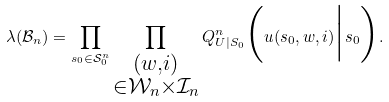Convert formula to latex. <formula><loc_0><loc_0><loc_500><loc_500>\lambda ( \mathcal { B } _ { n } ) = \prod _ { s _ { 0 } \in \mathcal { S } _ { 0 } ^ { n } } \prod _ { \substack { ( w , i ) \\ \in \mathcal { W } _ { n } \times \mathcal { I } _ { n } } } Q ^ { n } _ { U | S _ { 0 } } \Big ( u ( s _ { 0 } , w , i ) \Big | s _ { 0 } \Big ) .</formula> 